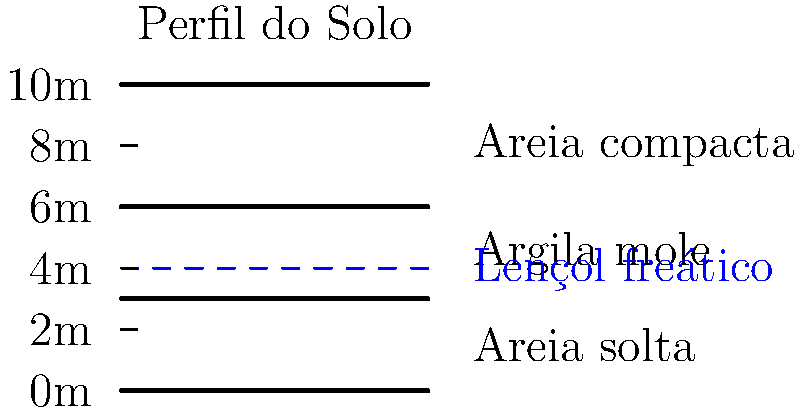Com base no perfil do solo apresentado, qual seria a profundidade mais adequada para a fundação de um edifício de médio porte, considerando a segurança cibernética e a proteção de dados sensíveis armazenados no local? Para determinar a profundidade mais adequada para a fundação, devemos considerar vários fatores:

1. Camadas do solo:
   - 0-3m: Areia solta (pouca capacidade de suporte)
   - 3-6m: Argila mole (baixa capacidade de suporte)
   - 6-10m: Areia compacta (boa capacidade de suporte)

2. Lençol freático: Localizado a 4m de profundidade

3. Segurança cibernética e proteção de dados:
   - Fundações mais profundas oferecem maior estabilidade e resistência a ameaças físicas

4. Análise:
   - A camada de areia compacta a partir de 6m oferece a melhor capacidade de suporte
   - Estar abaixo do lençol freático pode exigir medidas adicionais de impermeabilização
   - Uma fundação profunda nesta camada proporcionaria maior estabilidade e segurança

5. Conclusão:
   A profundidade mais adequada seria entre 7-8m, garantindo que a fundação esteja bem ancorada na camada de areia compacta, proporcionando estabilidade estrutural e maior segurança física para os dados armazenados.
Answer: 7-8m de profundidade 